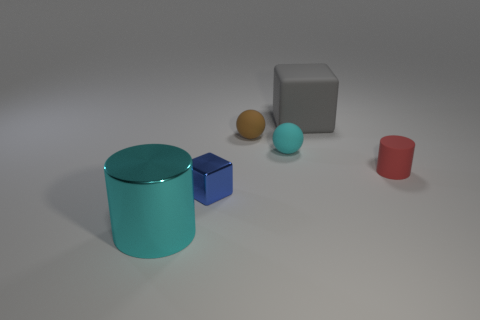Add 1 tiny brown spheres. How many objects exist? 7 Subtract all spheres. How many objects are left? 4 Add 4 big gray shiny balls. How many big gray shiny balls exist? 4 Subtract 0 red spheres. How many objects are left? 6 Subtract all rubber spheres. Subtract all blue objects. How many objects are left? 3 Add 5 cyan matte things. How many cyan matte things are left? 6 